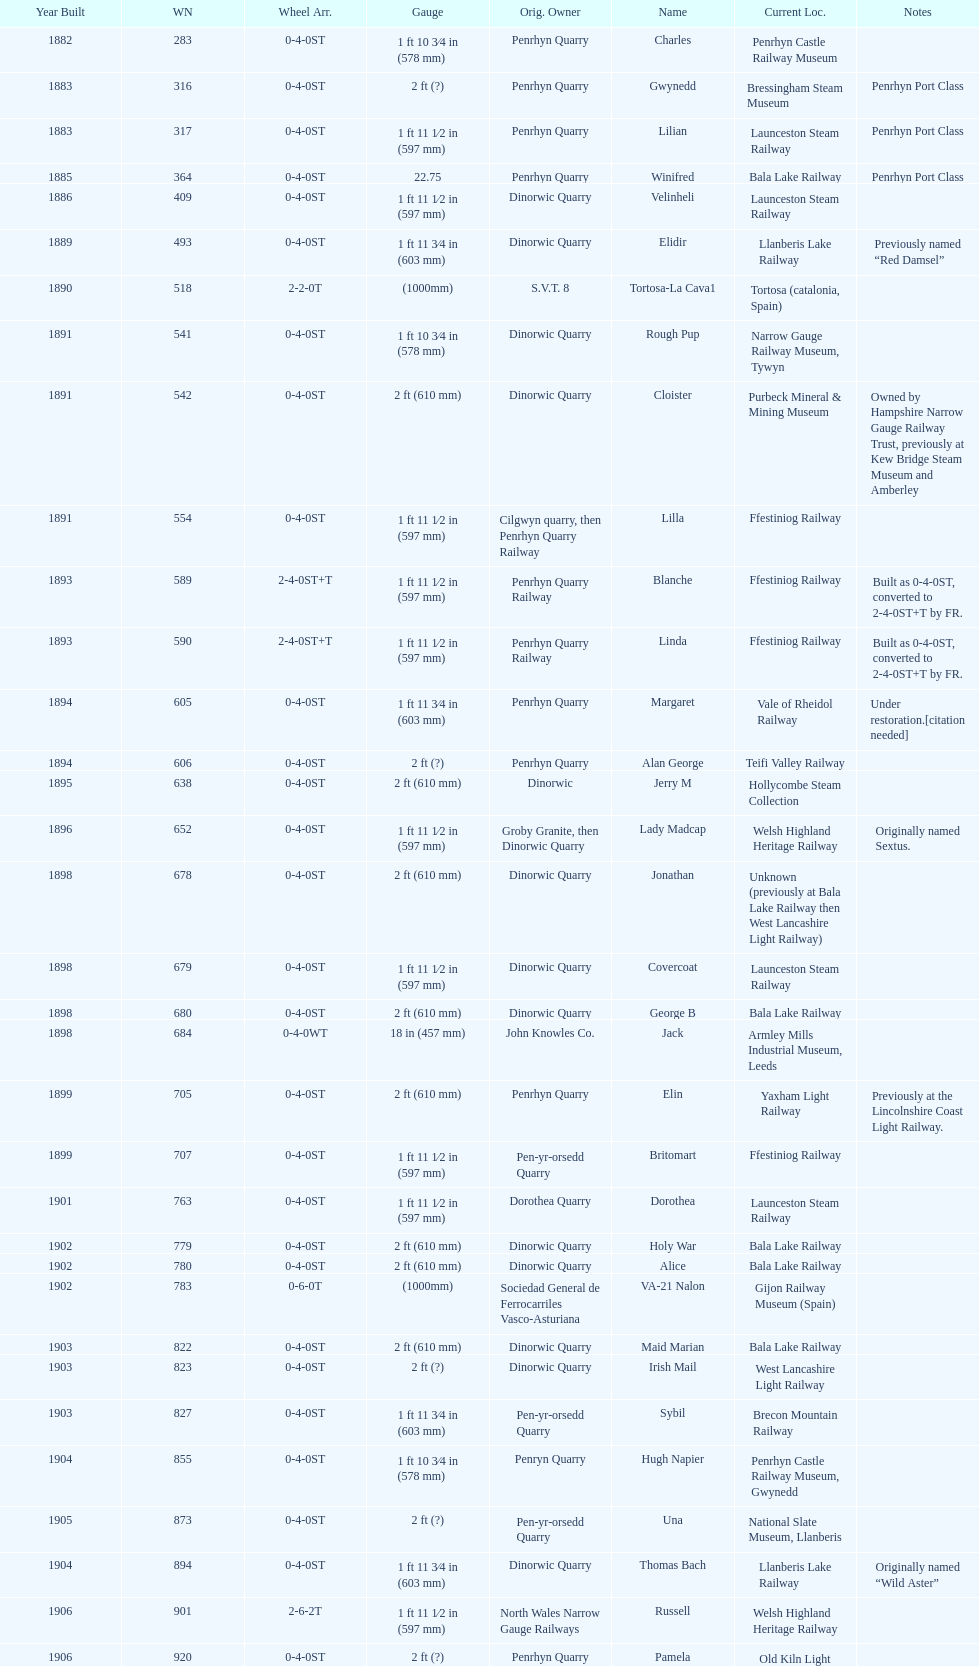What is the works number of the only item built in 1882? 283. 